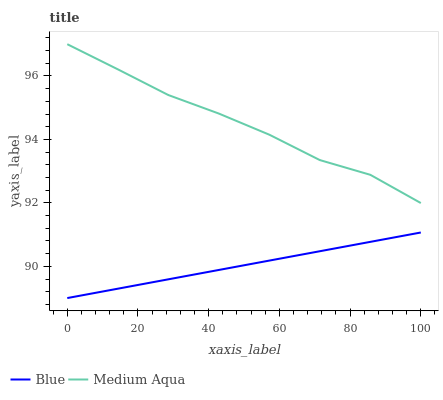Does Blue have the minimum area under the curve?
Answer yes or no. Yes. Does Medium Aqua have the maximum area under the curve?
Answer yes or no. Yes. Does Medium Aqua have the minimum area under the curve?
Answer yes or no. No. Is Blue the smoothest?
Answer yes or no. Yes. Is Medium Aqua the roughest?
Answer yes or no. Yes. Is Medium Aqua the smoothest?
Answer yes or no. No. Does Blue have the lowest value?
Answer yes or no. Yes. Does Medium Aqua have the lowest value?
Answer yes or no. No. Does Medium Aqua have the highest value?
Answer yes or no. Yes. Is Blue less than Medium Aqua?
Answer yes or no. Yes. Is Medium Aqua greater than Blue?
Answer yes or no. Yes. Does Blue intersect Medium Aqua?
Answer yes or no. No. 